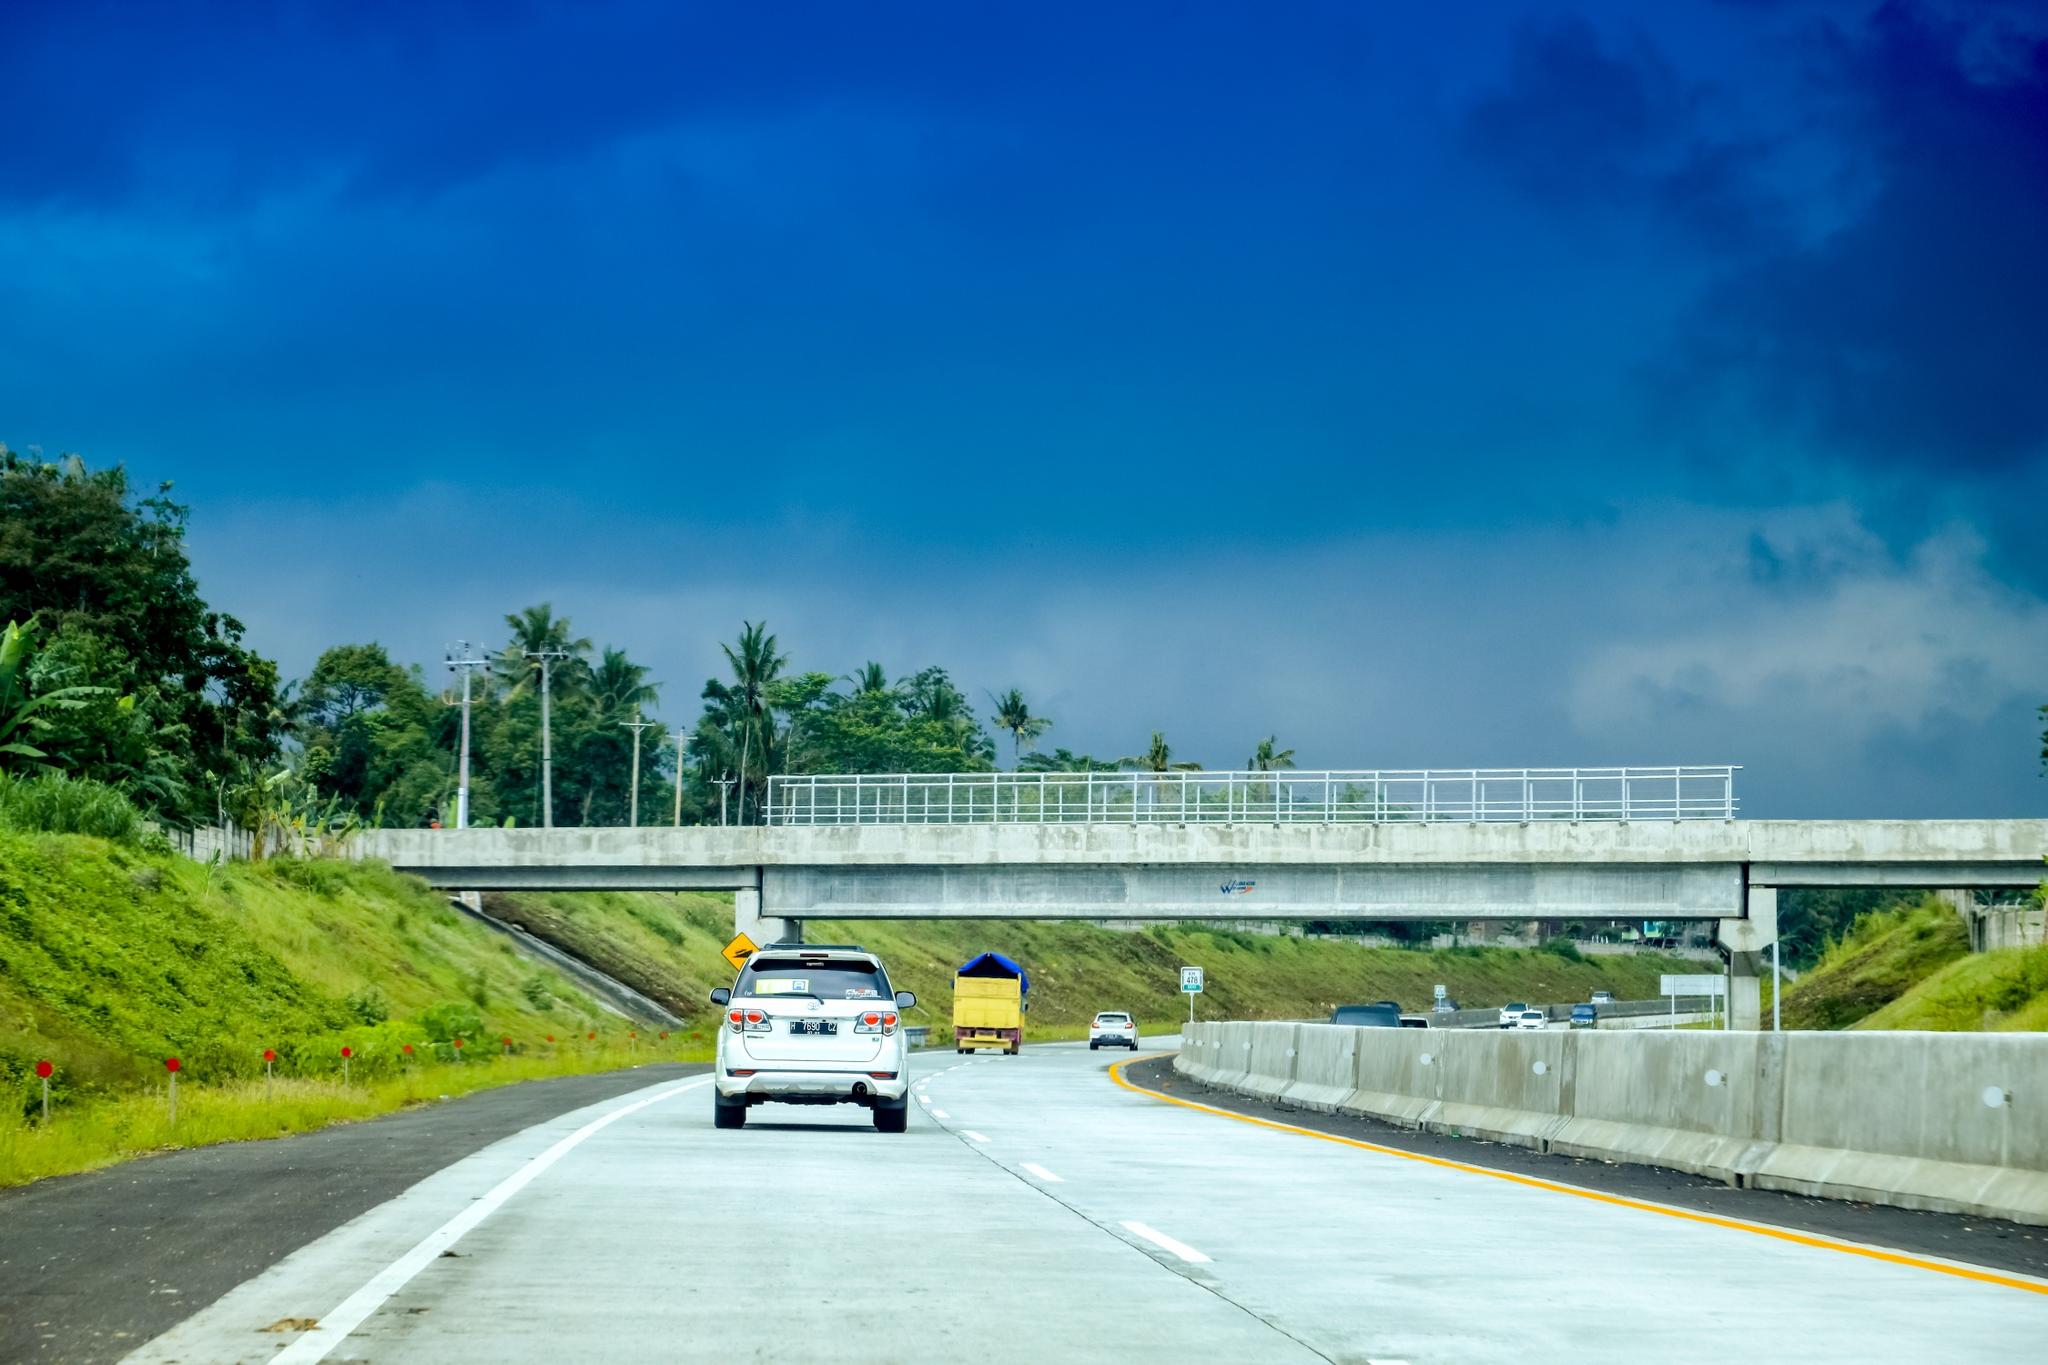Unleash your wildest imagination. What could possibly be happening beneath that clear blue sky? Beneath the clear blue sky, directly above the highway, a fleet of invisible airships hovers, cloaked by advanced technology. Unknown to the drivers below, a secret society of sky travelers, who live amongst the clouds, is conducting their annual meeting. Their mission: to protect Earth from unseen cosmic threats. Today, they are particularly focused on a rip in the fabric of reality, which happens to be directly above this scenic highway. As the cars drive blissfully unaware, the sky travelers employ sophisticated tech to silently repair the tear and ensure the continued safety of this world, maintaining the serene visage seen from the ground. 